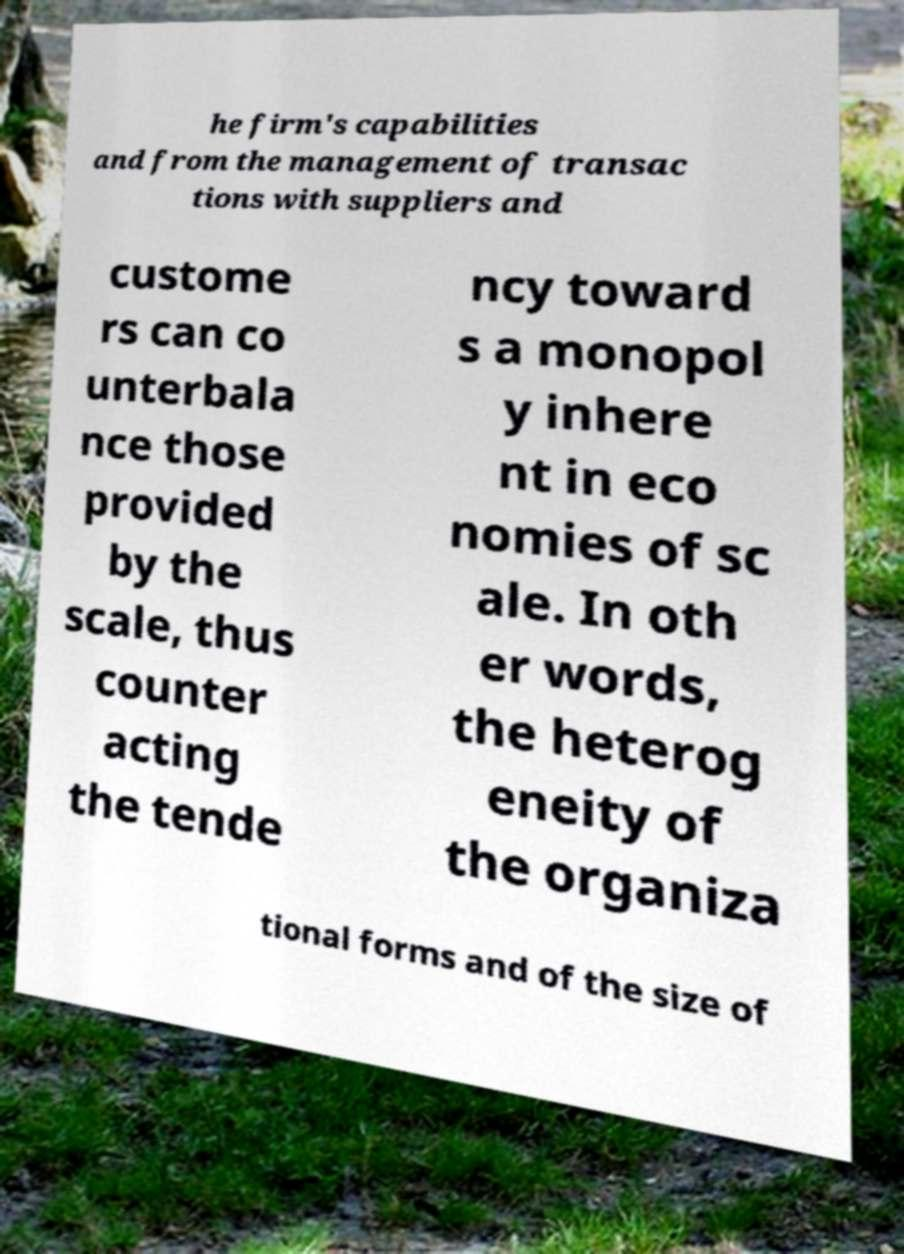There's text embedded in this image that I need extracted. Can you transcribe it verbatim? he firm's capabilities and from the management of transac tions with suppliers and custome rs can co unterbala nce those provided by the scale, thus counter acting the tende ncy toward s a monopol y inhere nt in eco nomies of sc ale. In oth er words, the heterog eneity of the organiza tional forms and of the size of 